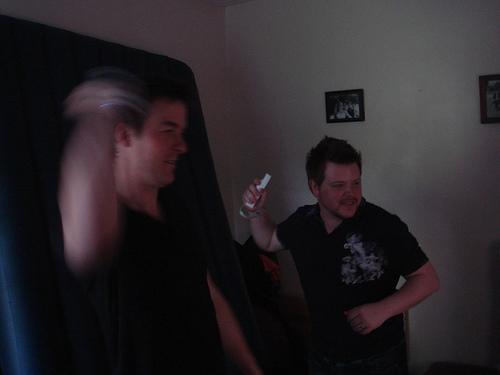Is anyone wearing glasses?
Short answer required. No. What are the blue figures on the man's shirt?
Give a very brief answer. Dolphins. Why is the picture blurry?
Answer briefly. Movement. Are they both wearing black?
Give a very brief answer. Yes. What are they playing?
Concise answer only. Wii. Are all the humans relatively same age?
Keep it brief. Yes. Is there a door in the room?
Answer briefly. No. Is there women in the picture?
Keep it brief. No. How many men are there?
Concise answer only. 2. Are these two people engaged in the same activity?
Answer briefly. Yes. How many boys are shown?
Answer briefly. 2. Is the man on the left in motion?
Write a very short answer. Yes. How many people are in the photograph in the background?
Keep it brief. 2. What is the man holding?
Short answer required. Wii controller. What is hanging on the wall?
Give a very brief answer. Picture. What are the people doing?
Quick response, please. Playing wii. Was this taken at a special event?
Short answer required. No. 